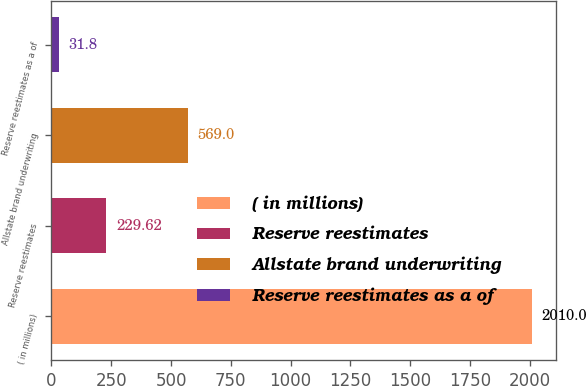Convert chart. <chart><loc_0><loc_0><loc_500><loc_500><bar_chart><fcel>( in millions)<fcel>Reserve reestimates<fcel>Allstate brand underwriting<fcel>Reserve reestimates as a of<nl><fcel>2010<fcel>229.62<fcel>569<fcel>31.8<nl></chart> 